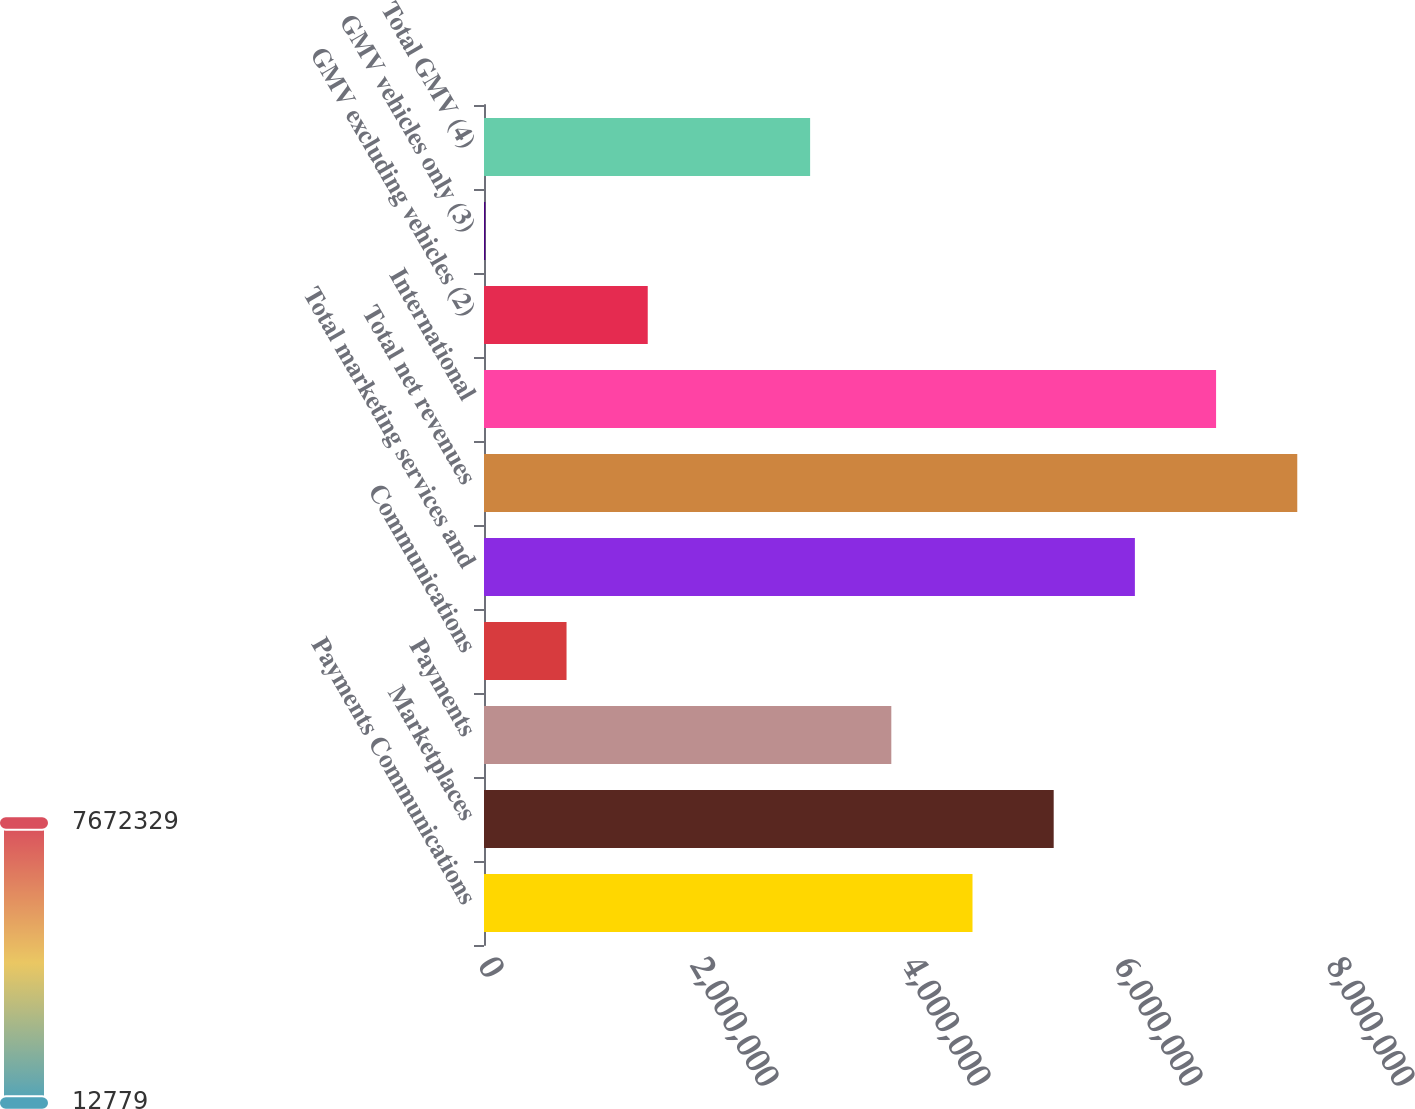<chart> <loc_0><loc_0><loc_500><loc_500><bar_chart><fcel>Payments Communications<fcel>Marketplaces<fcel>Payments<fcel>Communications<fcel>Total marketing services and<fcel>Total net revenues<fcel>International<fcel>GMV excluding vehicles (2)<fcel>GMV vehicles only (3)<fcel>Total GMV (4)<nl><fcel>4.60851e+06<fcel>5.37446e+06<fcel>3.84255e+06<fcel>778734<fcel>6.14042e+06<fcel>7.67233e+06<fcel>6.90637e+06<fcel>1.54469e+06<fcel>12779<fcel>3.0766e+06<nl></chart> 